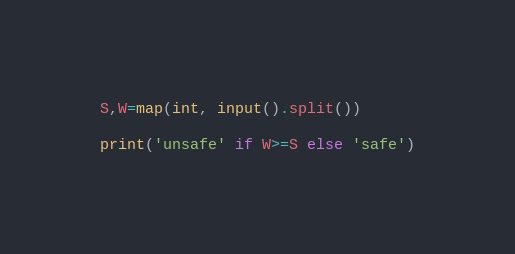Convert code to text. <code><loc_0><loc_0><loc_500><loc_500><_Python_>S,W=map(int, input().split())

print('unsafe' if W>=S else 'safe')</code> 